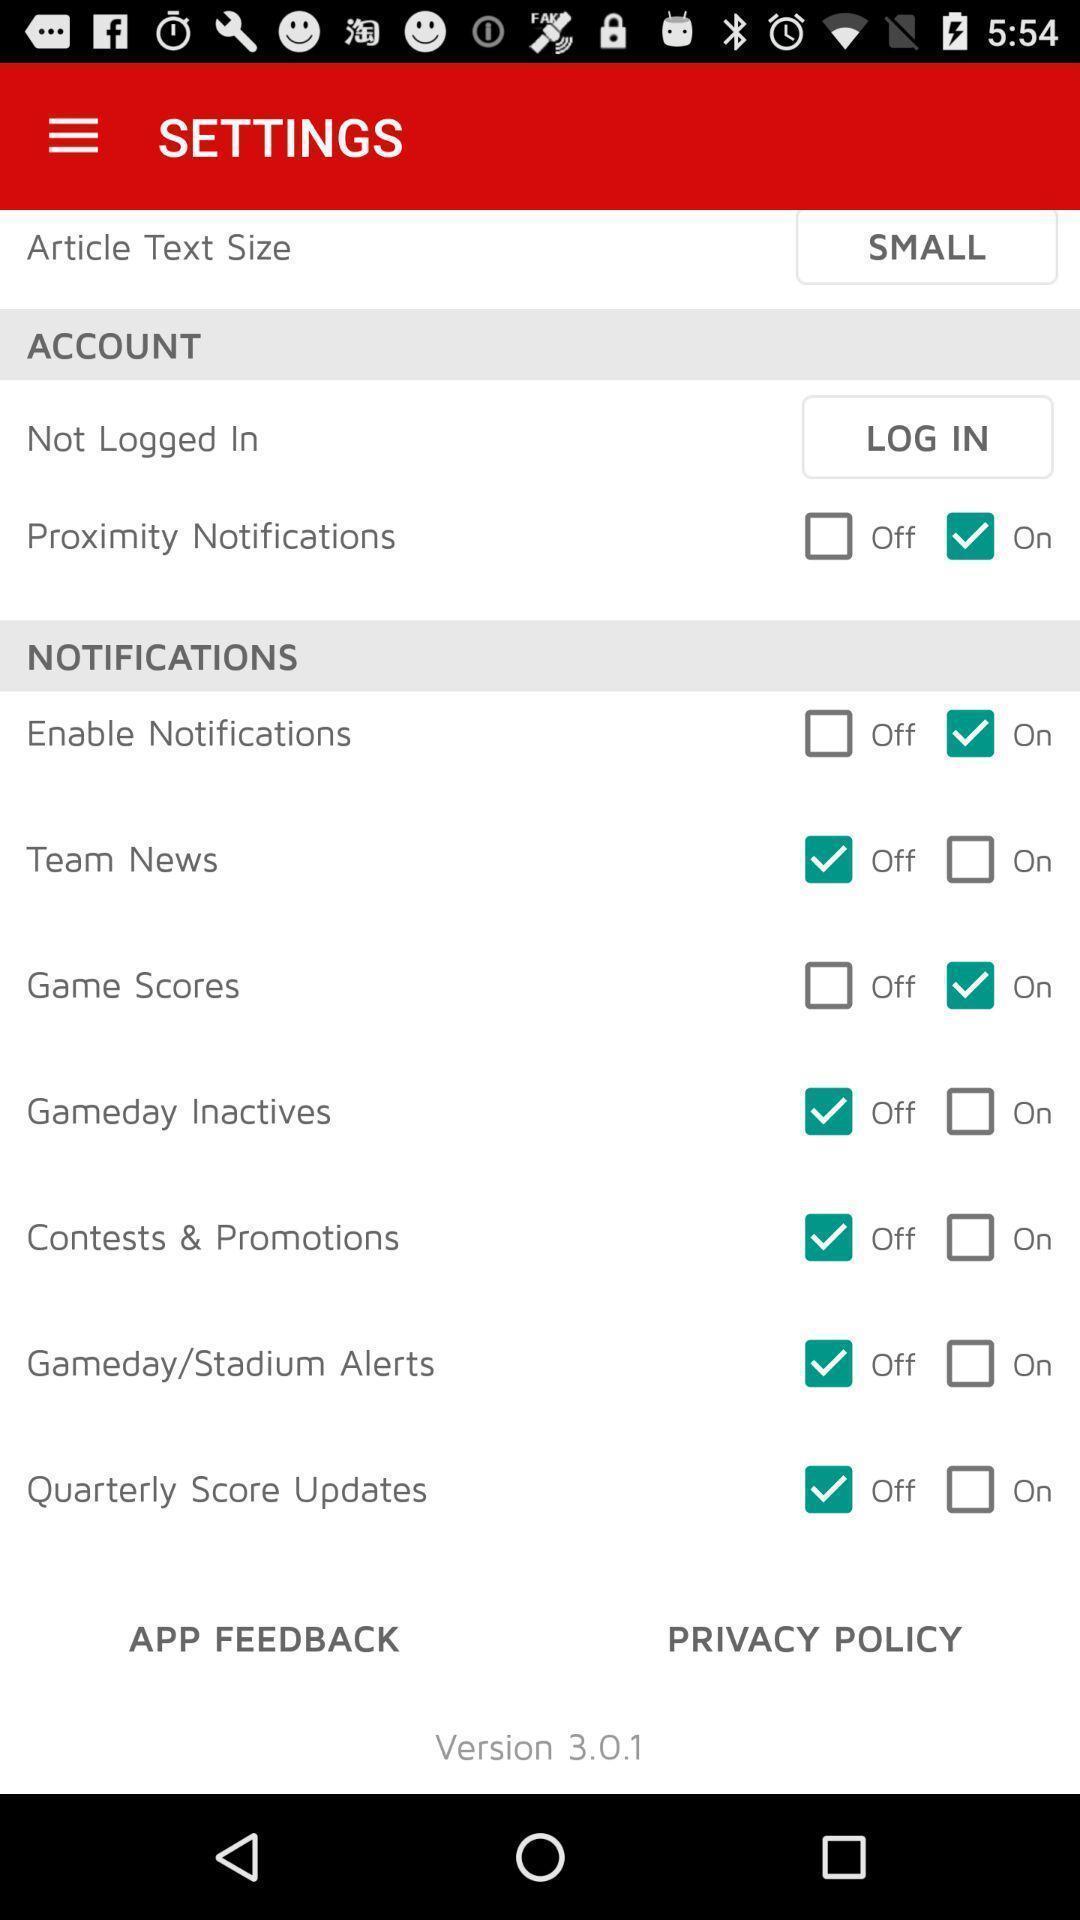What is the overall content of this screenshot? Settings page with list in a mobile. 